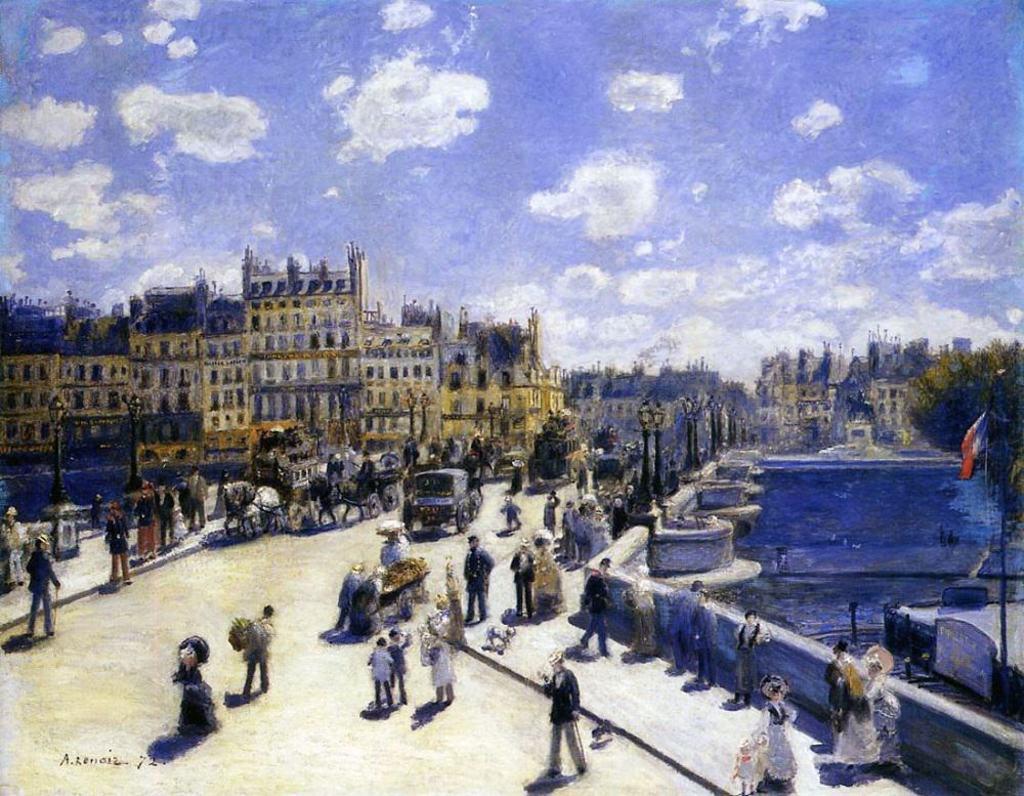In one or two sentences, can you explain what this image depicts? This image is a painting. In this image we can see vehicles and persons in the center of the image. On the right side of the image we can see water, flag, trees and buildings. On the left side of the image we can see persons, vehicles and buildings. In the background there are clouds and sky. 